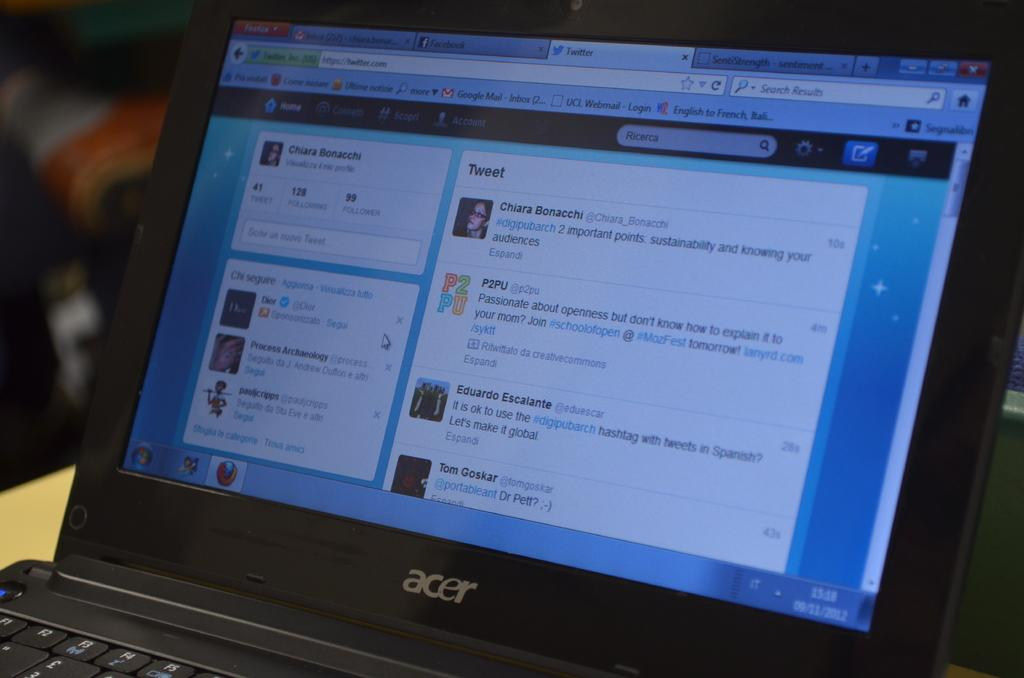<image>
Write a terse but informative summary of the picture. a laptop screen that has the word tweet on it 